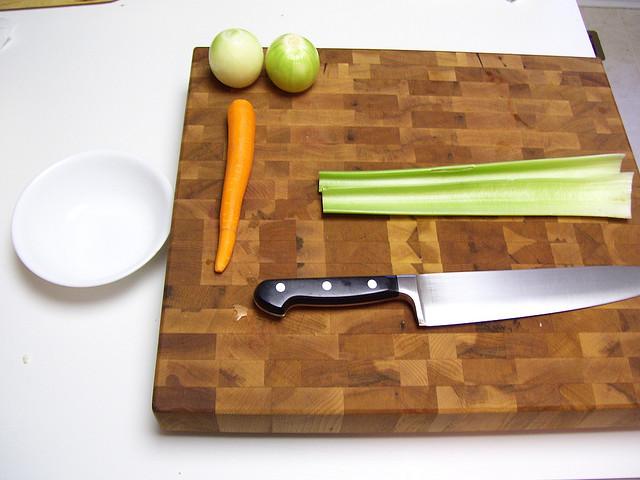How many stalks of celery are there?
Quick response, please. 2. What color is the handle of the knife?
Be succinct. Black. How many onions?
Be succinct. 2. How many carrots are there?
Concise answer only. 1. 